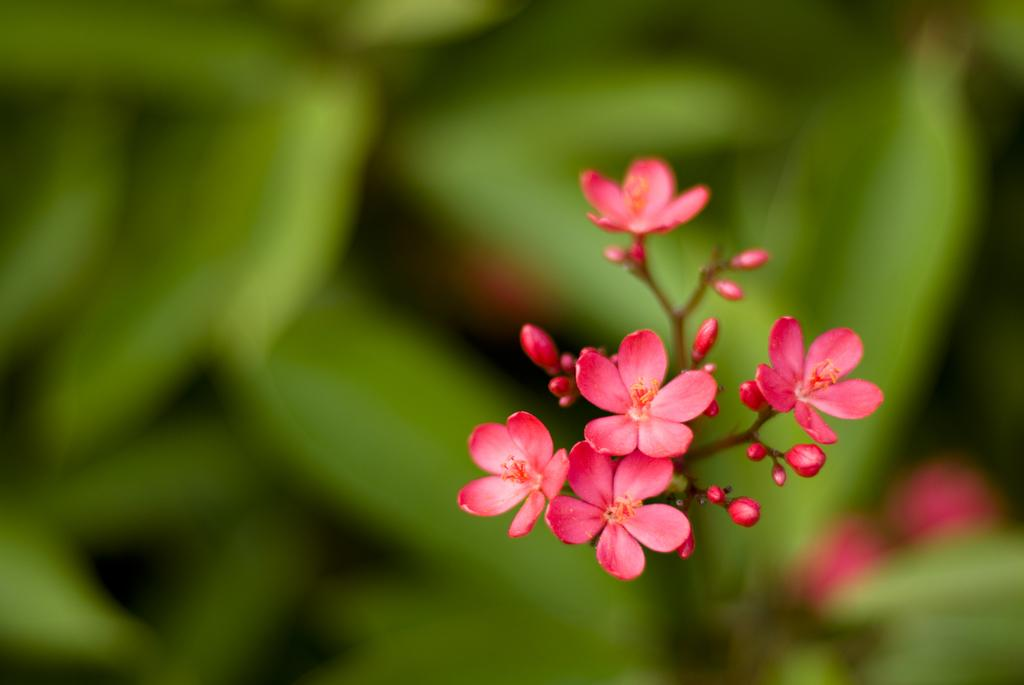What type of plants are in the image? There are flowers in the image. What color are the flowers? The flowers are pink in color. What else can be seen in the image besides the flowers? Leafs are visible in the image. How many eyes can be seen on the duck in the image? There is no duck present in the image; it features flowers and leafs. What type of faucet is visible in the image? There is no faucet present in the image; it features flowers and leafs. 